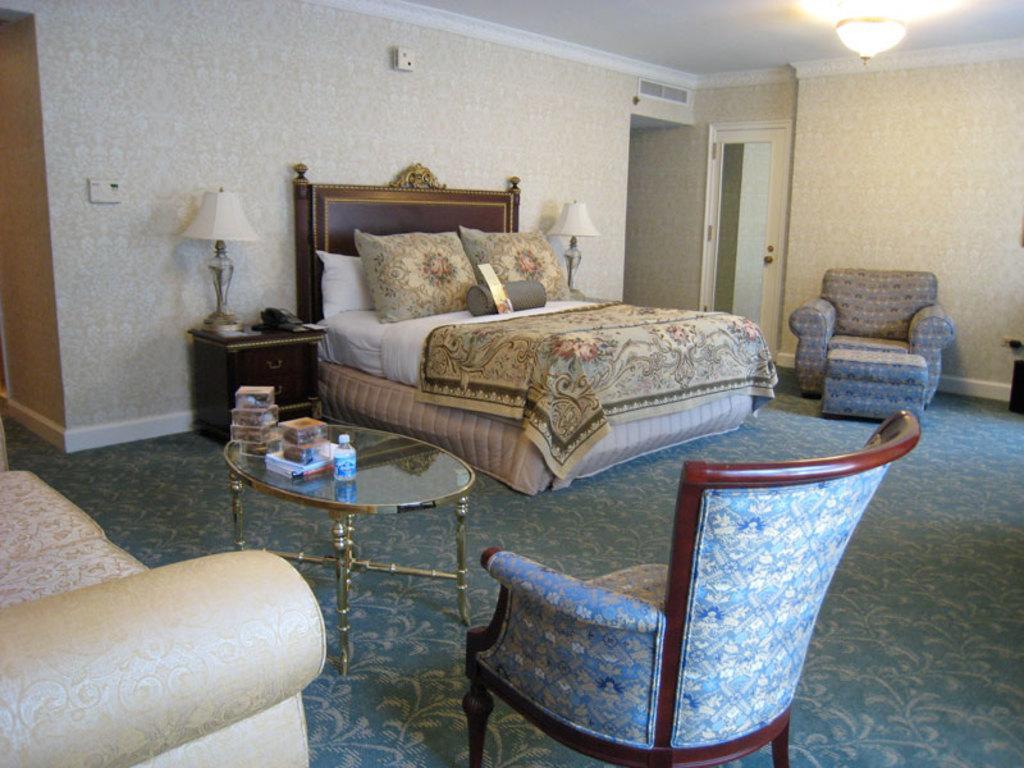Can you describe this image briefly? The picture is clicked inside a house where there are unoccupied sofas ,chairs and there is a beautiful bed and in the background we also observe two lamps on the both sides of the bed. There is a glass door in the background. 